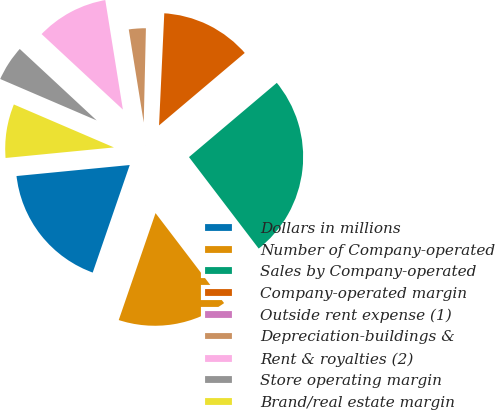Convert chart. <chart><loc_0><loc_0><loc_500><loc_500><pie_chart><fcel>Dollars in millions<fcel>Number of Company-operated<fcel>Sales by Company-operated<fcel>Company-operated margin<fcel>Outside rent expense (1)<fcel>Depreciation-buildings &<fcel>Rent & royalties (2)<fcel>Store operating margin<fcel>Brand/real estate margin<nl><fcel>18.18%<fcel>15.64%<fcel>25.81%<fcel>13.09%<fcel>0.37%<fcel>2.91%<fcel>10.55%<fcel>5.46%<fcel>8.0%<nl></chart> 